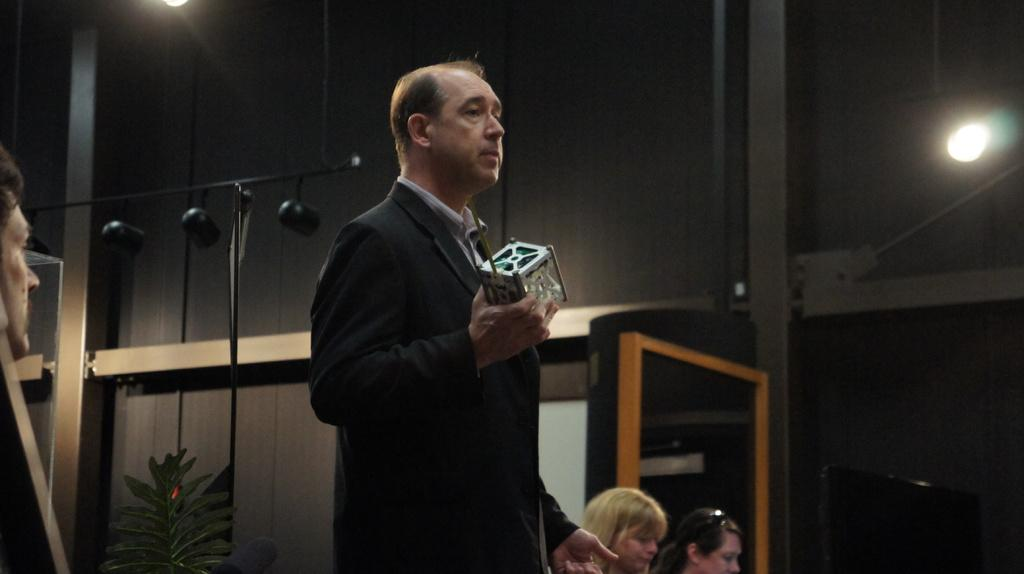What is the position of the person in the image? There is a person standing at the front in the image. What is the person wearing? The person is wearing a suit. What is the person holding in his hand? The person is holding an object in his hand. Can you describe the other people present in the image? There are other people present in the image, but their specific details are not mentioned in the facts. What is visible at the top of the image? There are lights at the top of the image. What type of credit can be seen on the person's neck in the image? There is no credit or necklace visible on the person in the image. What kind of apple is being used as a prop in the image? There is no apple present in the image. 